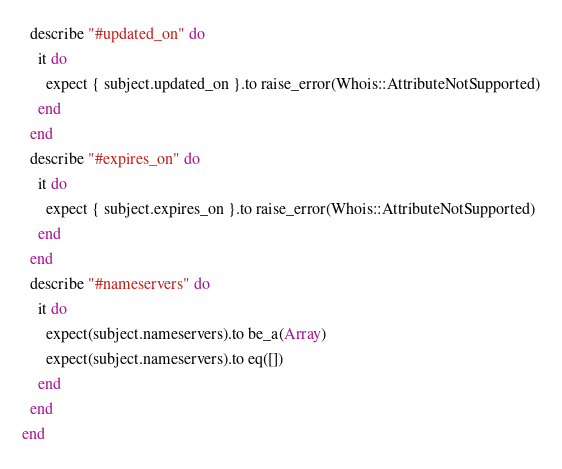<code> <loc_0><loc_0><loc_500><loc_500><_Ruby_>  describe "#updated_on" do
    it do
      expect { subject.updated_on }.to raise_error(Whois::AttributeNotSupported)
    end
  end
  describe "#expires_on" do
    it do
      expect { subject.expires_on }.to raise_error(Whois::AttributeNotSupported)
    end
  end
  describe "#nameservers" do
    it do
      expect(subject.nameservers).to be_a(Array)
      expect(subject.nameservers).to eq([])
    end
  end
end
</code> 